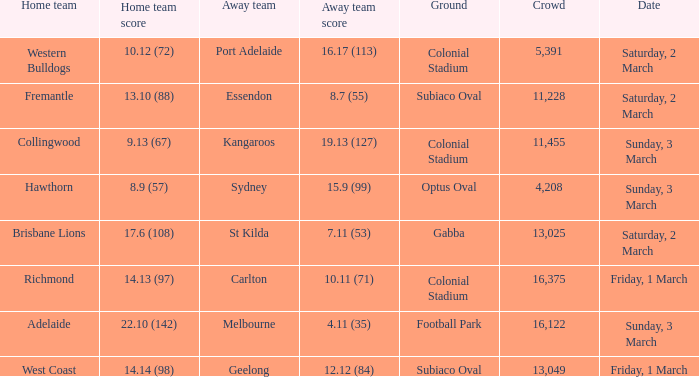Who is the away team when the home team scored 17.6 (108)? St Kilda. 